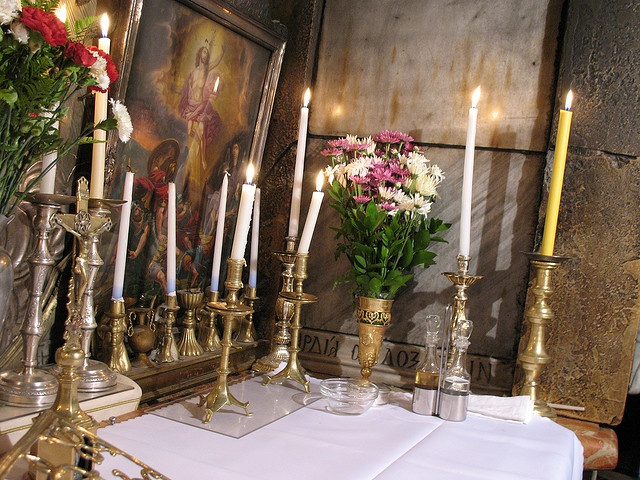Describe the objects in this image and their specific colors. I can see dining table in tan, lavender, darkgray, and lightgray tones, bowl in tan, darkgray, lightgray, and gray tones, vase in tan, olive, gray, and maroon tones, bottle in tan, darkgray, gray, and lightgray tones, and bottle in tan, gray, maroon, and darkgray tones in this image. 